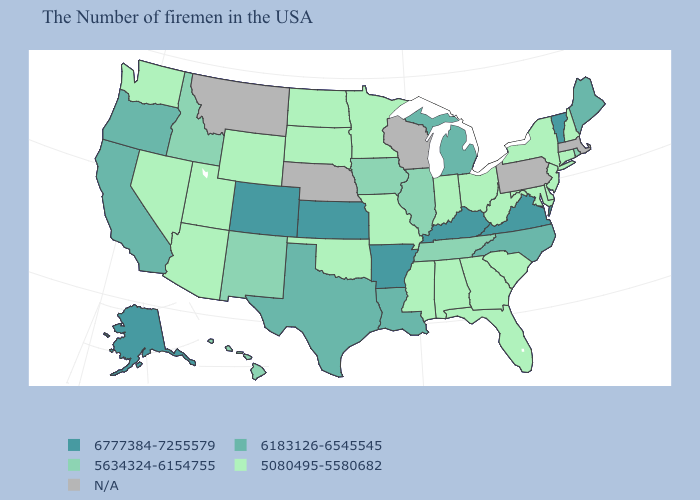How many symbols are there in the legend?
Write a very short answer. 5. Is the legend a continuous bar?
Concise answer only. No. Does Vermont have the highest value in the Northeast?
Write a very short answer. Yes. What is the value of West Virginia?
Keep it brief. 5080495-5580682. What is the highest value in the USA?
Give a very brief answer. 6777384-7255579. Name the states that have a value in the range 5080495-5580682?
Concise answer only. New Hampshire, Connecticut, New York, New Jersey, Delaware, Maryland, South Carolina, West Virginia, Ohio, Florida, Georgia, Indiana, Alabama, Mississippi, Missouri, Minnesota, Oklahoma, South Dakota, North Dakota, Wyoming, Utah, Arizona, Nevada, Washington. What is the value of Iowa?
Give a very brief answer. 5634324-6154755. Name the states that have a value in the range 6183126-6545545?
Keep it brief. Maine, North Carolina, Michigan, Louisiana, Texas, California, Oregon. What is the value of New York?
Be succinct. 5080495-5580682. Name the states that have a value in the range N/A?
Short answer required. Massachusetts, Pennsylvania, Wisconsin, Nebraska, Montana. What is the highest value in the USA?
Be succinct. 6777384-7255579. Which states have the lowest value in the USA?
Quick response, please. New Hampshire, Connecticut, New York, New Jersey, Delaware, Maryland, South Carolina, West Virginia, Ohio, Florida, Georgia, Indiana, Alabama, Mississippi, Missouri, Minnesota, Oklahoma, South Dakota, North Dakota, Wyoming, Utah, Arizona, Nevada, Washington. Name the states that have a value in the range 6183126-6545545?
Keep it brief. Maine, North Carolina, Michigan, Louisiana, Texas, California, Oregon. 